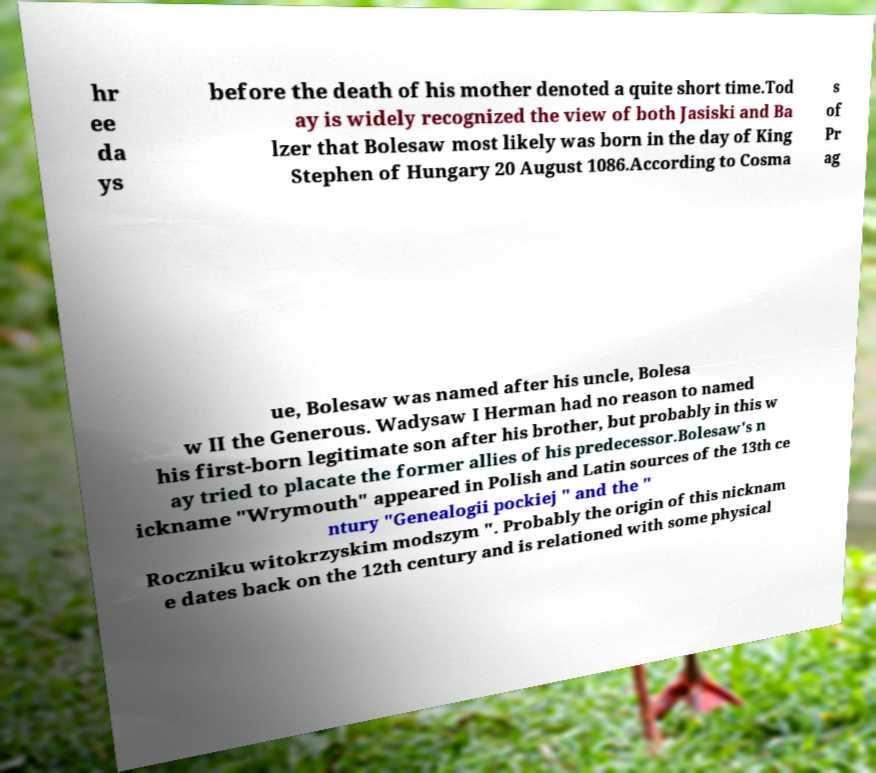Please identify and transcribe the text found in this image. hr ee da ys before the death of his mother denoted a quite short time.Tod ay is widely recognized the view of both Jasiski and Ba lzer that Bolesaw most likely was born in the day of King Stephen of Hungary 20 August 1086.According to Cosma s of Pr ag ue, Bolesaw was named after his uncle, Bolesa w II the Generous. Wadysaw I Herman had no reason to named his first-born legitimate son after his brother, but probably in this w ay tried to placate the former allies of his predecessor.Bolesaw's n ickname "Wrymouth" appeared in Polish and Latin sources of the 13th ce ntury "Genealogii pockiej " and the " Roczniku witokrzyskim modszym ". Probably the origin of this nicknam e dates back on the 12th century and is relationed with some physical 